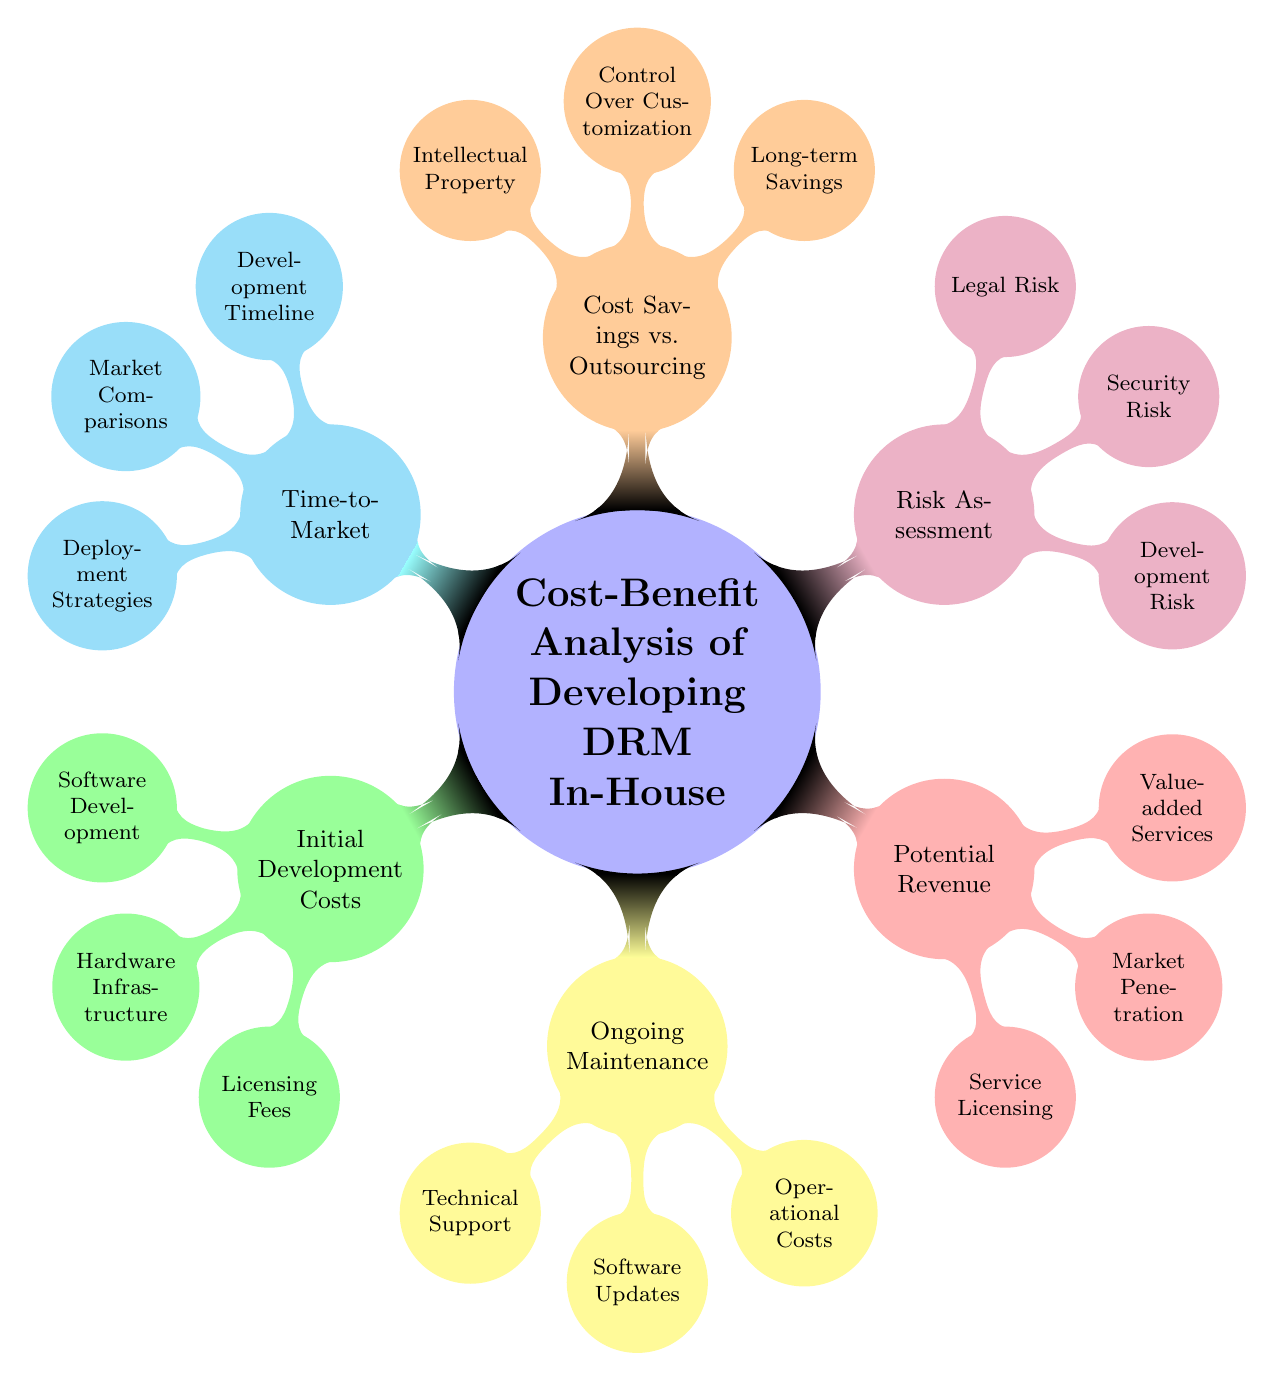What are the three main categories of the cost-benefit analysis? The diagram outlines three main categories: Initial Development Costs, Ongoing Maintenance, and Potential Revenue, among others. These can be identified directly as the first-level nodes branching from the main concept.
Answer: Initial Development Costs, Ongoing Maintenance, Potential Revenue How many sub-nodes does "Risk Assessment" have? "Risk Assessment" has three sub-nodes: Development Risk, Security Risk, and Legal Risk. This can be counted directly from the branches extending from the "Risk Assessment" node in the diagram.
Answer: 3 What is represented under "Potential Revenue"? The "Potential Revenue" node includes Service Licensing, Market Penetration, and Value-added Services, which are visible as direct sub-nodes.
Answer: Service Licensing, Market Penetration, Value-added Services Which node relates to the issue of "project delays"? "Project delays" are addressed under the "Risk Assessment" category, specifically in the "Development Risk" sub-node. This connection can be made by tracing the branch from the main concept to the relevant sub-node.
Answer: Development Risk What are the components included in "Initial Development Costs"? The components under "Initial Development Costs" listed in the diagram are Software Development, Hardware Infrastructure, and Licensing Fees. This information can be extracted by looking at the sub-nodes of the Initial Development Costs node.
Answer: Software Development, Hardware Infrastructure, Licensing Fees How does "Control Over Customization" relate to outsourcing? "Control Over Customization" implies that in-house development allows for full customization specific to needs, which suggests a key advantage over outsourcing, as depicted in the diagram under the Cost Savings versus Outsourcing node.
Answer: Full customization Which aspect of "Ongoing Maintenance" directly involves updates? "Software Updates" directly involves maintaining the system to ensure it functions correctly over time, which is highlighted as a sub-node under Ongoing Maintenance in the diagram.
Answer: Software Updates What advantage does "Intellectual Property" provide? "Intellectual Property" under Cost Savings versus Outsourcing refers to the ownership of proprietary technology, providing an advantage that outsourcing cannot offer. This can be identified by examining the connections in the respective node.
Answer: Ownership of proprietary technology 